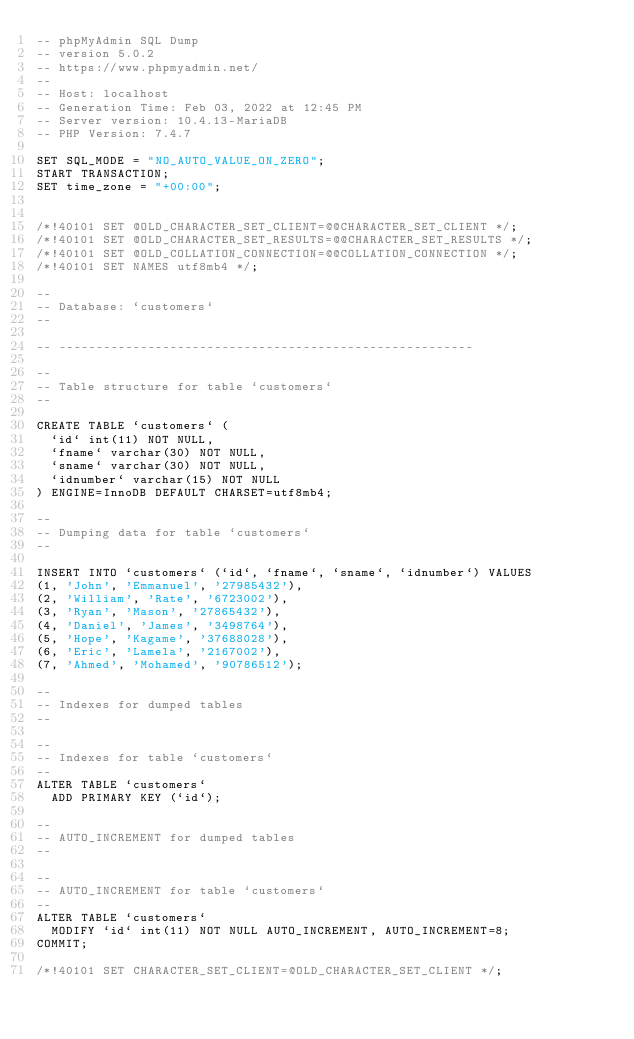<code> <loc_0><loc_0><loc_500><loc_500><_SQL_>-- phpMyAdmin SQL Dump
-- version 5.0.2
-- https://www.phpmyadmin.net/
--
-- Host: localhost
-- Generation Time: Feb 03, 2022 at 12:45 PM
-- Server version: 10.4.13-MariaDB
-- PHP Version: 7.4.7

SET SQL_MODE = "NO_AUTO_VALUE_ON_ZERO";
START TRANSACTION;
SET time_zone = "+00:00";


/*!40101 SET @OLD_CHARACTER_SET_CLIENT=@@CHARACTER_SET_CLIENT */;
/*!40101 SET @OLD_CHARACTER_SET_RESULTS=@@CHARACTER_SET_RESULTS */;
/*!40101 SET @OLD_COLLATION_CONNECTION=@@COLLATION_CONNECTION */;
/*!40101 SET NAMES utf8mb4 */;

--
-- Database: `customers`
--

-- --------------------------------------------------------

--
-- Table structure for table `customers`
--

CREATE TABLE `customers` (
  `id` int(11) NOT NULL,
  `fname` varchar(30) NOT NULL,
  `sname` varchar(30) NOT NULL,
  `idnumber` varchar(15) NOT NULL
) ENGINE=InnoDB DEFAULT CHARSET=utf8mb4;

--
-- Dumping data for table `customers`
--

INSERT INTO `customers` (`id`, `fname`, `sname`, `idnumber`) VALUES
(1, 'John', 'Emmanuel', '27985432'),
(2, 'William', 'Rate', '6723002'),
(3, 'Ryan', 'Mason', '27865432'),
(4, 'Daniel', 'James', '3498764'),
(5, 'Hope', 'Kagame', '37688028'),
(6, 'Eric', 'Lamela', '2167002'),
(7, 'Ahmed', 'Mohamed', '90786512');

--
-- Indexes for dumped tables
--

--
-- Indexes for table `customers`
--
ALTER TABLE `customers`
  ADD PRIMARY KEY (`id`);

--
-- AUTO_INCREMENT for dumped tables
--

--
-- AUTO_INCREMENT for table `customers`
--
ALTER TABLE `customers`
  MODIFY `id` int(11) NOT NULL AUTO_INCREMENT, AUTO_INCREMENT=8;
COMMIT;

/*!40101 SET CHARACTER_SET_CLIENT=@OLD_CHARACTER_SET_CLIENT */;</code> 